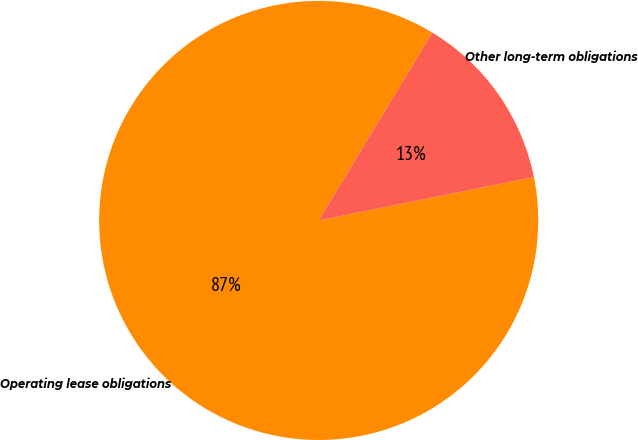<chart> <loc_0><loc_0><loc_500><loc_500><pie_chart><fcel>Operating lease obligations<fcel>Other long-term obligations<nl><fcel>86.82%<fcel>13.18%<nl></chart> 